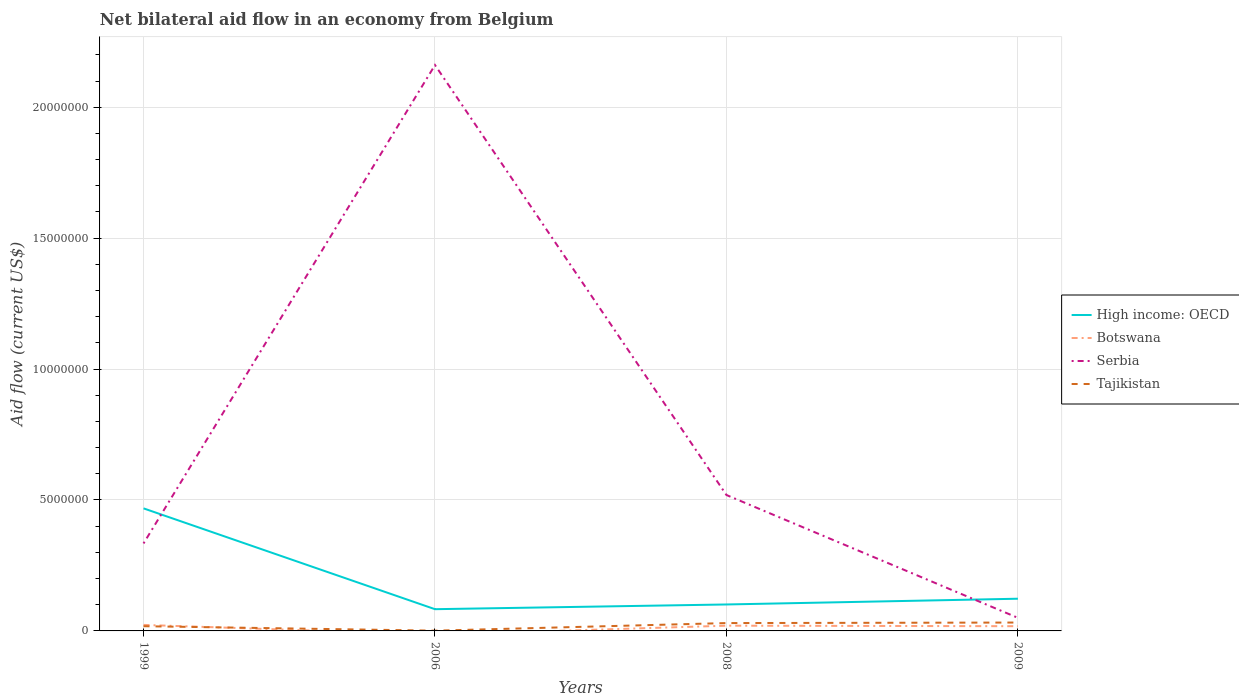Is the number of lines equal to the number of legend labels?
Your response must be concise. No. Across all years, what is the maximum net bilateral aid flow in High income: OECD?
Your answer should be very brief. 8.30e+05. What is the difference between the highest and the second highest net bilateral aid flow in Serbia?
Give a very brief answer. 2.11e+07. What is the difference between the highest and the lowest net bilateral aid flow in Serbia?
Provide a succinct answer. 1. How many lines are there?
Your response must be concise. 4. How many years are there in the graph?
Give a very brief answer. 4. What is the difference between two consecutive major ticks on the Y-axis?
Provide a short and direct response. 5.00e+06. Are the values on the major ticks of Y-axis written in scientific E-notation?
Ensure brevity in your answer.  No. Does the graph contain any zero values?
Ensure brevity in your answer.  Yes. Does the graph contain grids?
Offer a terse response. Yes. How many legend labels are there?
Provide a succinct answer. 4. How are the legend labels stacked?
Make the answer very short. Vertical. What is the title of the graph?
Provide a succinct answer. Net bilateral aid flow in an economy from Belgium. Does "Singapore" appear as one of the legend labels in the graph?
Keep it short and to the point. No. What is the Aid flow (current US$) of High income: OECD in 1999?
Your answer should be compact. 4.68e+06. What is the Aid flow (current US$) of Serbia in 1999?
Offer a very short reply. 3.34e+06. What is the Aid flow (current US$) of High income: OECD in 2006?
Make the answer very short. 8.30e+05. What is the Aid flow (current US$) in Botswana in 2006?
Your response must be concise. 0. What is the Aid flow (current US$) of Serbia in 2006?
Provide a short and direct response. 2.16e+07. What is the Aid flow (current US$) in Tajikistan in 2006?
Your response must be concise. 10000. What is the Aid flow (current US$) in High income: OECD in 2008?
Give a very brief answer. 1.01e+06. What is the Aid flow (current US$) of Serbia in 2008?
Offer a terse response. 5.19e+06. What is the Aid flow (current US$) of High income: OECD in 2009?
Your answer should be compact. 1.23e+06. What is the Aid flow (current US$) in Tajikistan in 2009?
Your response must be concise. 3.20e+05. Across all years, what is the maximum Aid flow (current US$) of High income: OECD?
Ensure brevity in your answer.  4.68e+06. Across all years, what is the maximum Aid flow (current US$) of Serbia?
Make the answer very short. 2.16e+07. Across all years, what is the minimum Aid flow (current US$) in High income: OECD?
Give a very brief answer. 8.30e+05. Across all years, what is the minimum Aid flow (current US$) of Serbia?
Keep it short and to the point. 5.00e+05. What is the total Aid flow (current US$) of High income: OECD in the graph?
Give a very brief answer. 7.75e+06. What is the total Aid flow (current US$) in Botswana in the graph?
Your response must be concise. 6.10e+05. What is the total Aid flow (current US$) of Serbia in the graph?
Offer a very short reply. 3.06e+07. What is the total Aid flow (current US$) in Tajikistan in the graph?
Give a very brief answer. 8.10e+05. What is the difference between the Aid flow (current US$) in High income: OECD in 1999 and that in 2006?
Ensure brevity in your answer.  3.85e+06. What is the difference between the Aid flow (current US$) in Serbia in 1999 and that in 2006?
Your response must be concise. -1.83e+07. What is the difference between the Aid flow (current US$) in High income: OECD in 1999 and that in 2008?
Ensure brevity in your answer.  3.67e+06. What is the difference between the Aid flow (current US$) in Serbia in 1999 and that in 2008?
Make the answer very short. -1.85e+06. What is the difference between the Aid flow (current US$) in High income: OECD in 1999 and that in 2009?
Your answer should be very brief. 3.45e+06. What is the difference between the Aid flow (current US$) in Serbia in 1999 and that in 2009?
Provide a succinct answer. 2.84e+06. What is the difference between the Aid flow (current US$) in Tajikistan in 1999 and that in 2009?
Provide a succinct answer. -1.40e+05. What is the difference between the Aid flow (current US$) of Serbia in 2006 and that in 2008?
Keep it short and to the point. 1.64e+07. What is the difference between the Aid flow (current US$) of Tajikistan in 2006 and that in 2008?
Your answer should be compact. -2.90e+05. What is the difference between the Aid flow (current US$) in High income: OECD in 2006 and that in 2009?
Offer a terse response. -4.00e+05. What is the difference between the Aid flow (current US$) of Serbia in 2006 and that in 2009?
Your response must be concise. 2.11e+07. What is the difference between the Aid flow (current US$) in Tajikistan in 2006 and that in 2009?
Provide a short and direct response. -3.10e+05. What is the difference between the Aid flow (current US$) in High income: OECD in 2008 and that in 2009?
Give a very brief answer. -2.20e+05. What is the difference between the Aid flow (current US$) in Serbia in 2008 and that in 2009?
Provide a short and direct response. 4.69e+06. What is the difference between the Aid flow (current US$) in High income: OECD in 1999 and the Aid flow (current US$) in Serbia in 2006?
Your answer should be very brief. -1.69e+07. What is the difference between the Aid flow (current US$) of High income: OECD in 1999 and the Aid flow (current US$) of Tajikistan in 2006?
Keep it short and to the point. 4.67e+06. What is the difference between the Aid flow (current US$) in Botswana in 1999 and the Aid flow (current US$) in Serbia in 2006?
Provide a short and direct response. -2.14e+07. What is the difference between the Aid flow (current US$) of Serbia in 1999 and the Aid flow (current US$) of Tajikistan in 2006?
Keep it short and to the point. 3.33e+06. What is the difference between the Aid flow (current US$) in High income: OECD in 1999 and the Aid flow (current US$) in Botswana in 2008?
Offer a terse response. 4.48e+06. What is the difference between the Aid flow (current US$) in High income: OECD in 1999 and the Aid flow (current US$) in Serbia in 2008?
Keep it short and to the point. -5.10e+05. What is the difference between the Aid flow (current US$) of High income: OECD in 1999 and the Aid flow (current US$) of Tajikistan in 2008?
Your answer should be compact. 4.38e+06. What is the difference between the Aid flow (current US$) in Botswana in 1999 and the Aid flow (current US$) in Serbia in 2008?
Give a very brief answer. -4.96e+06. What is the difference between the Aid flow (current US$) in Botswana in 1999 and the Aid flow (current US$) in Tajikistan in 2008?
Ensure brevity in your answer.  -7.00e+04. What is the difference between the Aid flow (current US$) of Serbia in 1999 and the Aid flow (current US$) of Tajikistan in 2008?
Your answer should be compact. 3.04e+06. What is the difference between the Aid flow (current US$) of High income: OECD in 1999 and the Aid flow (current US$) of Botswana in 2009?
Your answer should be very brief. 4.50e+06. What is the difference between the Aid flow (current US$) of High income: OECD in 1999 and the Aid flow (current US$) of Serbia in 2009?
Offer a terse response. 4.18e+06. What is the difference between the Aid flow (current US$) of High income: OECD in 1999 and the Aid flow (current US$) of Tajikistan in 2009?
Provide a succinct answer. 4.36e+06. What is the difference between the Aid flow (current US$) in Serbia in 1999 and the Aid flow (current US$) in Tajikistan in 2009?
Your response must be concise. 3.02e+06. What is the difference between the Aid flow (current US$) in High income: OECD in 2006 and the Aid flow (current US$) in Botswana in 2008?
Keep it short and to the point. 6.30e+05. What is the difference between the Aid flow (current US$) in High income: OECD in 2006 and the Aid flow (current US$) in Serbia in 2008?
Your response must be concise. -4.36e+06. What is the difference between the Aid flow (current US$) of High income: OECD in 2006 and the Aid flow (current US$) of Tajikistan in 2008?
Ensure brevity in your answer.  5.30e+05. What is the difference between the Aid flow (current US$) in Serbia in 2006 and the Aid flow (current US$) in Tajikistan in 2008?
Offer a terse response. 2.13e+07. What is the difference between the Aid flow (current US$) in High income: OECD in 2006 and the Aid flow (current US$) in Botswana in 2009?
Your answer should be very brief. 6.50e+05. What is the difference between the Aid flow (current US$) in High income: OECD in 2006 and the Aid flow (current US$) in Serbia in 2009?
Offer a very short reply. 3.30e+05. What is the difference between the Aid flow (current US$) of High income: OECD in 2006 and the Aid flow (current US$) of Tajikistan in 2009?
Your response must be concise. 5.10e+05. What is the difference between the Aid flow (current US$) of Serbia in 2006 and the Aid flow (current US$) of Tajikistan in 2009?
Offer a very short reply. 2.13e+07. What is the difference between the Aid flow (current US$) in High income: OECD in 2008 and the Aid flow (current US$) in Botswana in 2009?
Your response must be concise. 8.30e+05. What is the difference between the Aid flow (current US$) of High income: OECD in 2008 and the Aid flow (current US$) of Serbia in 2009?
Your response must be concise. 5.10e+05. What is the difference between the Aid flow (current US$) in High income: OECD in 2008 and the Aid flow (current US$) in Tajikistan in 2009?
Ensure brevity in your answer.  6.90e+05. What is the difference between the Aid flow (current US$) in Botswana in 2008 and the Aid flow (current US$) in Serbia in 2009?
Keep it short and to the point. -3.00e+05. What is the difference between the Aid flow (current US$) in Serbia in 2008 and the Aid flow (current US$) in Tajikistan in 2009?
Provide a succinct answer. 4.87e+06. What is the average Aid flow (current US$) of High income: OECD per year?
Offer a terse response. 1.94e+06. What is the average Aid flow (current US$) in Botswana per year?
Your response must be concise. 1.52e+05. What is the average Aid flow (current US$) of Serbia per year?
Your answer should be compact. 7.66e+06. What is the average Aid flow (current US$) of Tajikistan per year?
Your response must be concise. 2.02e+05. In the year 1999, what is the difference between the Aid flow (current US$) in High income: OECD and Aid flow (current US$) in Botswana?
Give a very brief answer. 4.45e+06. In the year 1999, what is the difference between the Aid flow (current US$) in High income: OECD and Aid flow (current US$) in Serbia?
Your answer should be compact. 1.34e+06. In the year 1999, what is the difference between the Aid flow (current US$) of High income: OECD and Aid flow (current US$) of Tajikistan?
Ensure brevity in your answer.  4.50e+06. In the year 1999, what is the difference between the Aid flow (current US$) of Botswana and Aid flow (current US$) of Serbia?
Ensure brevity in your answer.  -3.11e+06. In the year 1999, what is the difference between the Aid flow (current US$) of Botswana and Aid flow (current US$) of Tajikistan?
Offer a terse response. 5.00e+04. In the year 1999, what is the difference between the Aid flow (current US$) of Serbia and Aid flow (current US$) of Tajikistan?
Your answer should be very brief. 3.16e+06. In the year 2006, what is the difference between the Aid flow (current US$) of High income: OECD and Aid flow (current US$) of Serbia?
Make the answer very short. -2.08e+07. In the year 2006, what is the difference between the Aid flow (current US$) of High income: OECD and Aid flow (current US$) of Tajikistan?
Provide a succinct answer. 8.20e+05. In the year 2006, what is the difference between the Aid flow (current US$) in Serbia and Aid flow (current US$) in Tajikistan?
Offer a terse response. 2.16e+07. In the year 2008, what is the difference between the Aid flow (current US$) of High income: OECD and Aid flow (current US$) of Botswana?
Provide a short and direct response. 8.10e+05. In the year 2008, what is the difference between the Aid flow (current US$) in High income: OECD and Aid flow (current US$) in Serbia?
Your answer should be compact. -4.18e+06. In the year 2008, what is the difference between the Aid flow (current US$) in High income: OECD and Aid flow (current US$) in Tajikistan?
Ensure brevity in your answer.  7.10e+05. In the year 2008, what is the difference between the Aid flow (current US$) of Botswana and Aid flow (current US$) of Serbia?
Offer a terse response. -4.99e+06. In the year 2008, what is the difference between the Aid flow (current US$) in Botswana and Aid flow (current US$) in Tajikistan?
Give a very brief answer. -1.00e+05. In the year 2008, what is the difference between the Aid flow (current US$) in Serbia and Aid flow (current US$) in Tajikistan?
Your response must be concise. 4.89e+06. In the year 2009, what is the difference between the Aid flow (current US$) of High income: OECD and Aid flow (current US$) of Botswana?
Keep it short and to the point. 1.05e+06. In the year 2009, what is the difference between the Aid flow (current US$) in High income: OECD and Aid flow (current US$) in Serbia?
Provide a short and direct response. 7.30e+05. In the year 2009, what is the difference between the Aid flow (current US$) of High income: OECD and Aid flow (current US$) of Tajikistan?
Your answer should be very brief. 9.10e+05. In the year 2009, what is the difference between the Aid flow (current US$) in Botswana and Aid flow (current US$) in Serbia?
Offer a terse response. -3.20e+05. In the year 2009, what is the difference between the Aid flow (current US$) of Botswana and Aid flow (current US$) of Tajikistan?
Your response must be concise. -1.40e+05. In the year 2009, what is the difference between the Aid flow (current US$) of Serbia and Aid flow (current US$) of Tajikistan?
Your answer should be very brief. 1.80e+05. What is the ratio of the Aid flow (current US$) of High income: OECD in 1999 to that in 2006?
Give a very brief answer. 5.64. What is the ratio of the Aid flow (current US$) of Serbia in 1999 to that in 2006?
Ensure brevity in your answer.  0.15. What is the ratio of the Aid flow (current US$) in High income: OECD in 1999 to that in 2008?
Ensure brevity in your answer.  4.63. What is the ratio of the Aid flow (current US$) of Botswana in 1999 to that in 2008?
Keep it short and to the point. 1.15. What is the ratio of the Aid flow (current US$) in Serbia in 1999 to that in 2008?
Keep it short and to the point. 0.64. What is the ratio of the Aid flow (current US$) of High income: OECD in 1999 to that in 2009?
Give a very brief answer. 3.8. What is the ratio of the Aid flow (current US$) in Botswana in 1999 to that in 2009?
Your response must be concise. 1.28. What is the ratio of the Aid flow (current US$) of Serbia in 1999 to that in 2009?
Offer a very short reply. 6.68. What is the ratio of the Aid flow (current US$) of Tajikistan in 1999 to that in 2009?
Ensure brevity in your answer.  0.56. What is the ratio of the Aid flow (current US$) in High income: OECD in 2006 to that in 2008?
Offer a very short reply. 0.82. What is the ratio of the Aid flow (current US$) of Serbia in 2006 to that in 2008?
Keep it short and to the point. 4.16. What is the ratio of the Aid flow (current US$) in High income: OECD in 2006 to that in 2009?
Provide a succinct answer. 0.67. What is the ratio of the Aid flow (current US$) in Serbia in 2006 to that in 2009?
Ensure brevity in your answer.  43.22. What is the ratio of the Aid flow (current US$) of Tajikistan in 2006 to that in 2009?
Your response must be concise. 0.03. What is the ratio of the Aid flow (current US$) in High income: OECD in 2008 to that in 2009?
Provide a short and direct response. 0.82. What is the ratio of the Aid flow (current US$) of Botswana in 2008 to that in 2009?
Keep it short and to the point. 1.11. What is the ratio of the Aid flow (current US$) in Serbia in 2008 to that in 2009?
Ensure brevity in your answer.  10.38. What is the ratio of the Aid flow (current US$) in Tajikistan in 2008 to that in 2009?
Offer a terse response. 0.94. What is the difference between the highest and the second highest Aid flow (current US$) of High income: OECD?
Offer a terse response. 3.45e+06. What is the difference between the highest and the second highest Aid flow (current US$) of Botswana?
Make the answer very short. 3.00e+04. What is the difference between the highest and the second highest Aid flow (current US$) of Serbia?
Your answer should be compact. 1.64e+07. What is the difference between the highest and the lowest Aid flow (current US$) in High income: OECD?
Provide a succinct answer. 3.85e+06. What is the difference between the highest and the lowest Aid flow (current US$) of Botswana?
Keep it short and to the point. 2.30e+05. What is the difference between the highest and the lowest Aid flow (current US$) in Serbia?
Your answer should be very brief. 2.11e+07. What is the difference between the highest and the lowest Aid flow (current US$) of Tajikistan?
Offer a very short reply. 3.10e+05. 